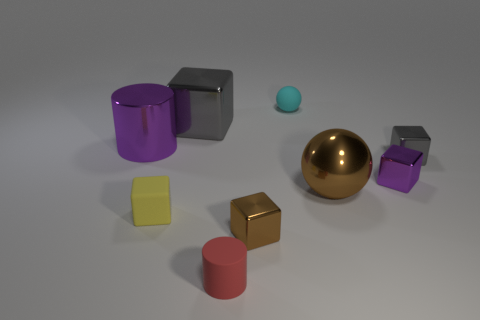What shape is the tiny metallic object that is the same color as the big sphere?
Keep it short and to the point. Cube. What is the object in front of the small brown metal object made of?
Make the answer very short. Rubber. What number of things are either green cylinders or brown metal things right of the cyan ball?
Your response must be concise. 1. What is the shape of the red matte thing that is the same size as the purple shiny cube?
Your answer should be very brief. Cylinder. What number of shiny cubes have the same color as the metal cylinder?
Provide a succinct answer. 1. Is the gray thing that is to the right of the small brown block made of the same material as the big purple cylinder?
Give a very brief answer. Yes. The big brown thing has what shape?
Keep it short and to the point. Sphere. How many yellow objects are either large cylinders or large shiny cubes?
Your answer should be compact. 0. How many other objects are there of the same material as the big purple thing?
Your response must be concise. 5. Is the shape of the gray object in front of the large gray cube the same as  the large gray metal thing?
Make the answer very short. Yes. 